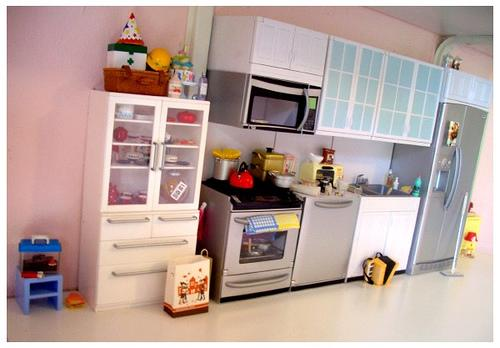What type of people obviously live here? Please explain your reasoning. children. Kids have a lot of toys so they must live here. 